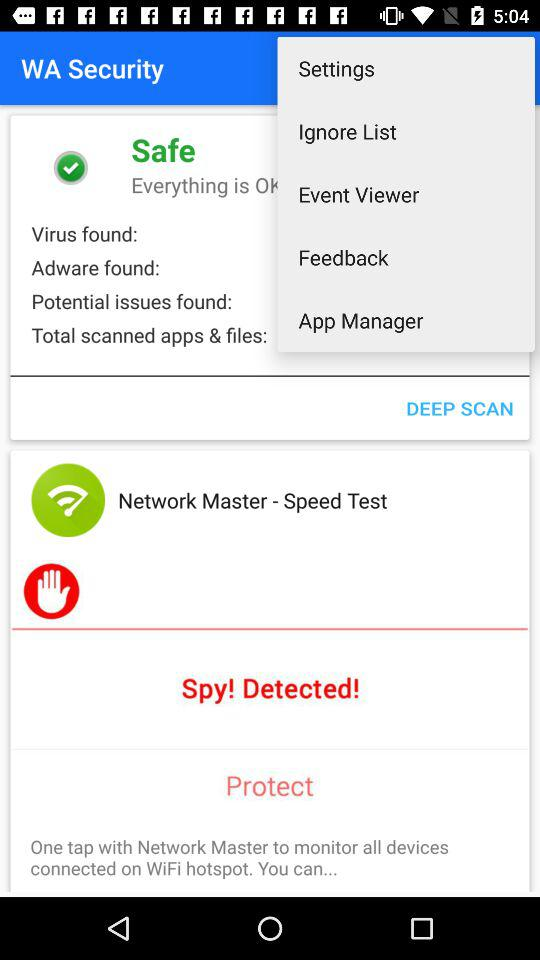How many adware are there? There is 0 adware. 